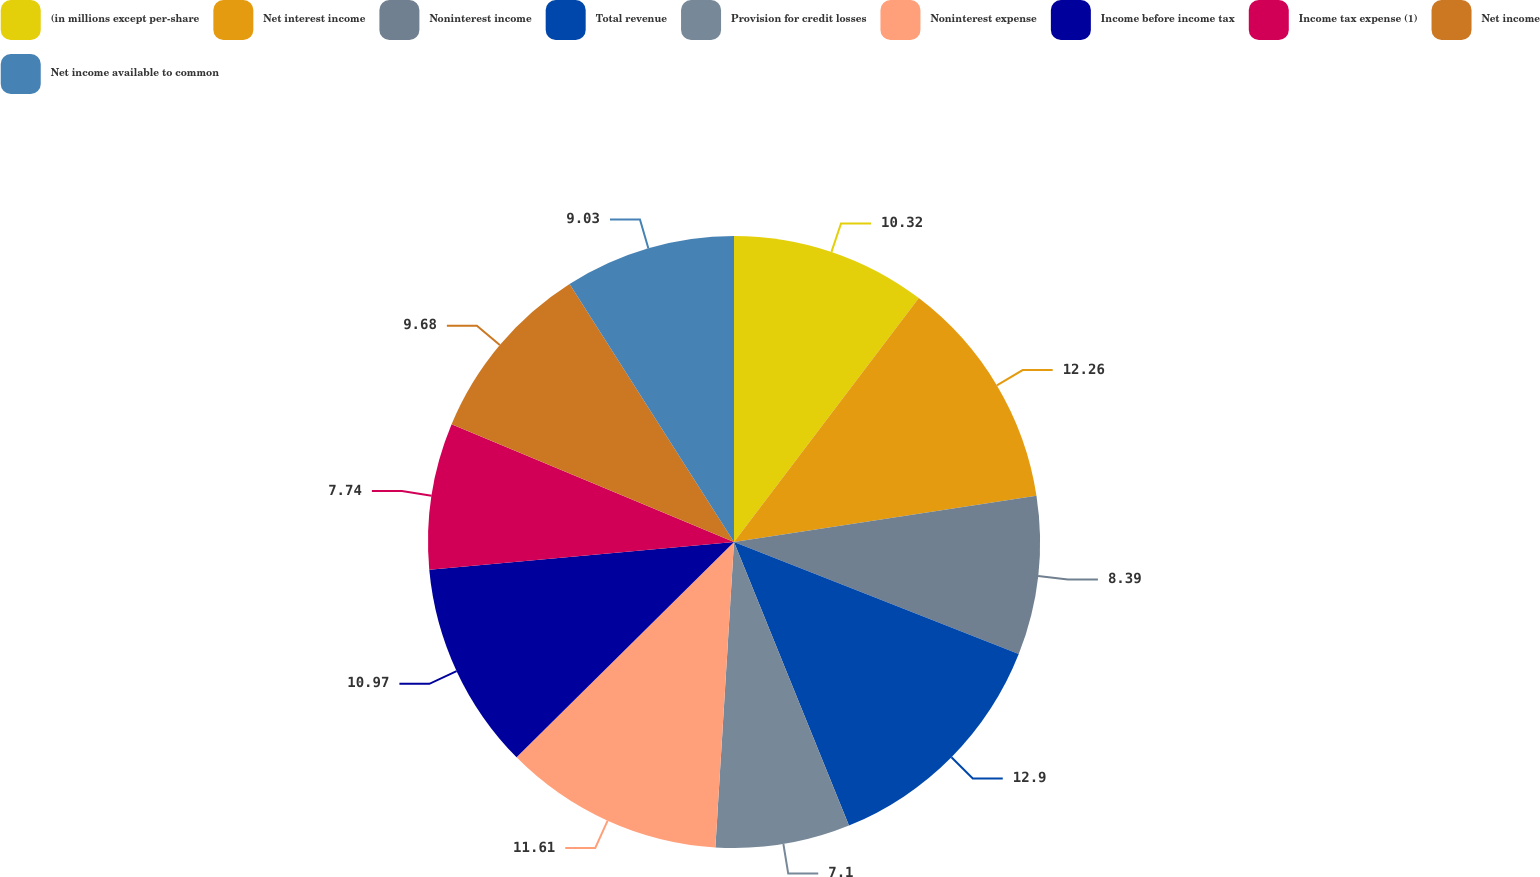Convert chart to OTSL. <chart><loc_0><loc_0><loc_500><loc_500><pie_chart><fcel>(in millions except per-share<fcel>Net interest income<fcel>Noninterest income<fcel>Total revenue<fcel>Provision for credit losses<fcel>Noninterest expense<fcel>Income before income tax<fcel>Income tax expense (1)<fcel>Net income<fcel>Net income available to common<nl><fcel>10.32%<fcel>12.26%<fcel>8.39%<fcel>12.9%<fcel>7.1%<fcel>11.61%<fcel>10.97%<fcel>7.74%<fcel>9.68%<fcel>9.03%<nl></chart> 